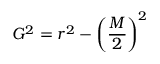<formula> <loc_0><loc_0><loc_500><loc_500>{ } G ^ { 2 } = r ^ { 2 } - \left ( { \frac { M } { 2 } } \right ) ^ { 2 }</formula> 